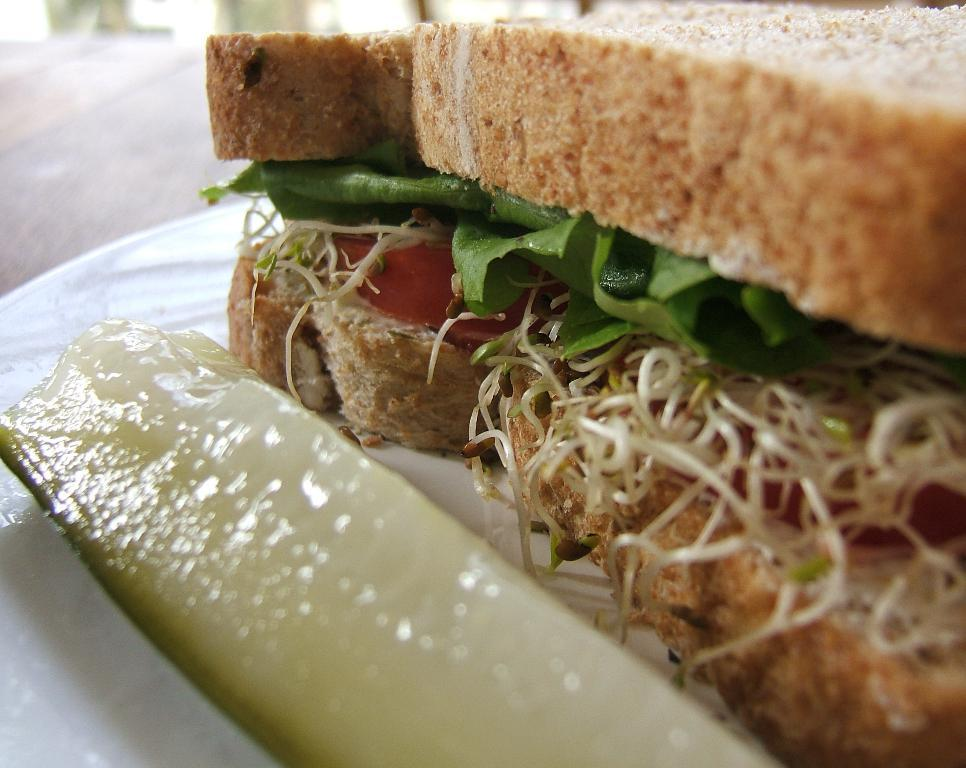What is on the table in the image? There is a plate on the table in the image. What is on the plate? The plate contains bread. What is unique about the bread on the plate? The bread is stuffed with some food. What is the distance between the bread and the man in the image? There is no man present in the image, so it is not possible to determine the distance between the bread and a man. 